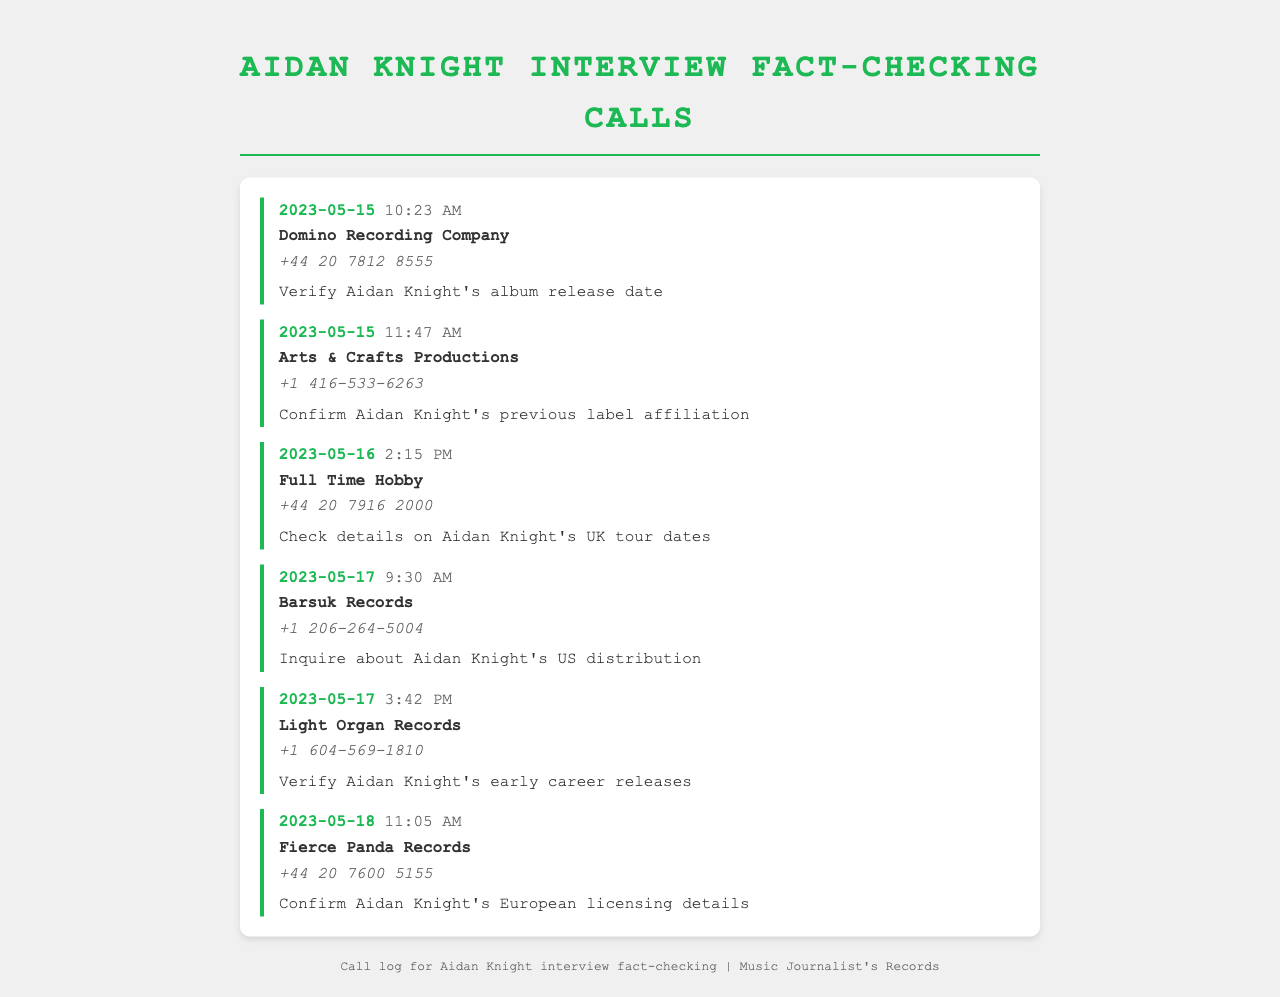What date did Aidan Knight call Domino Recording Company? The date of the call to Domino Recording Company is specified in the document.
Answer: 2023-05-15 What was the purpose of the call to Arts & Crafts Productions? The document states the reason for the call, which involves Aidan Knight's label affiliation.
Answer: Confirm Aidan Knight's previous label affiliation What is the telephone number for Full Time Hobby? The document lists the contact number for Full Time Hobby clearly.
Answer: +44 20 7916 2000 How many times did Aidan Knight call on May 17? The document provides a count of the entries for May 17, which can be summed.
Answer: 2 Which record label was contacted to verify Aidan Knight's early career releases? The document explicitly names the record label related to Aidan Knight's early career.
Answer: Light Organ Records What time did the call to Fierce Panda Records occur? The call time is recorded in the entry for Fierce Panda Records, as listed in the document.
Answer: 11:05 AM Which call occurred just before the call to Barsuk Records? The document arranges the calls by date and time, allowing the identification of the preceding call.
Answer: Light Organ Records What is the main topic of the call to verify Aidan Knight's album release date? The purpose of the call is outlined in the entry, specifically regarding the album release.
Answer: Verify Aidan Knight's album release date How many different record labels are mentioned in the document? The document lists distinct entries that represent different record labels associated with the calls made.
Answer: 6 